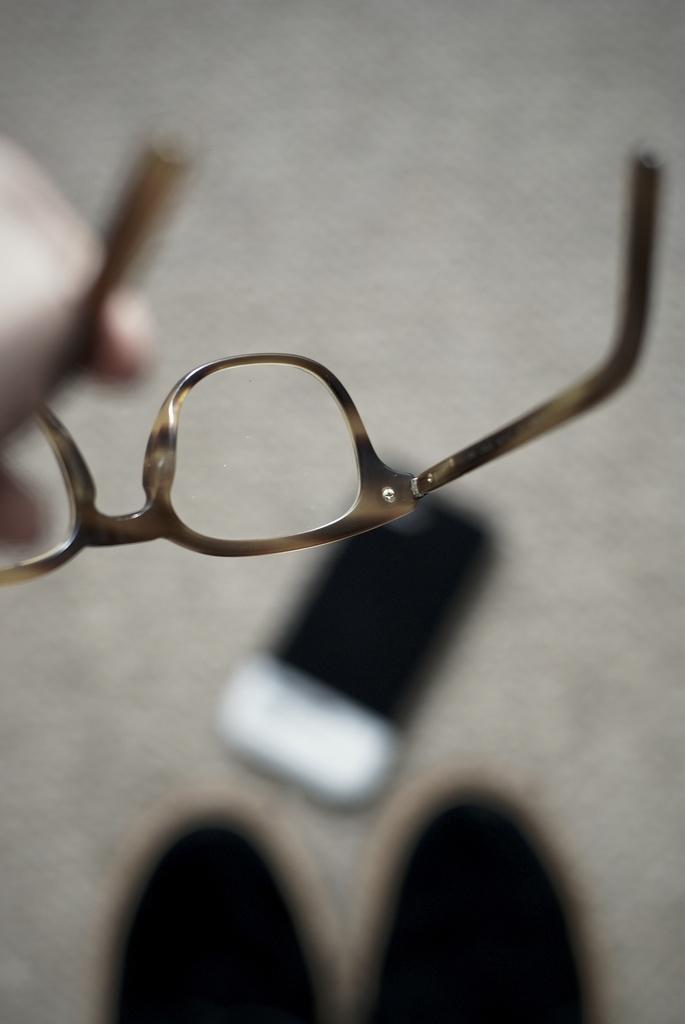Could you give a brief overview of what you see in this image? In this image it seems like there is one human hand is holding a spects we can see on the left side of this image and it seems like there is a mobile phone kept on the floor is in the middle of this image. 